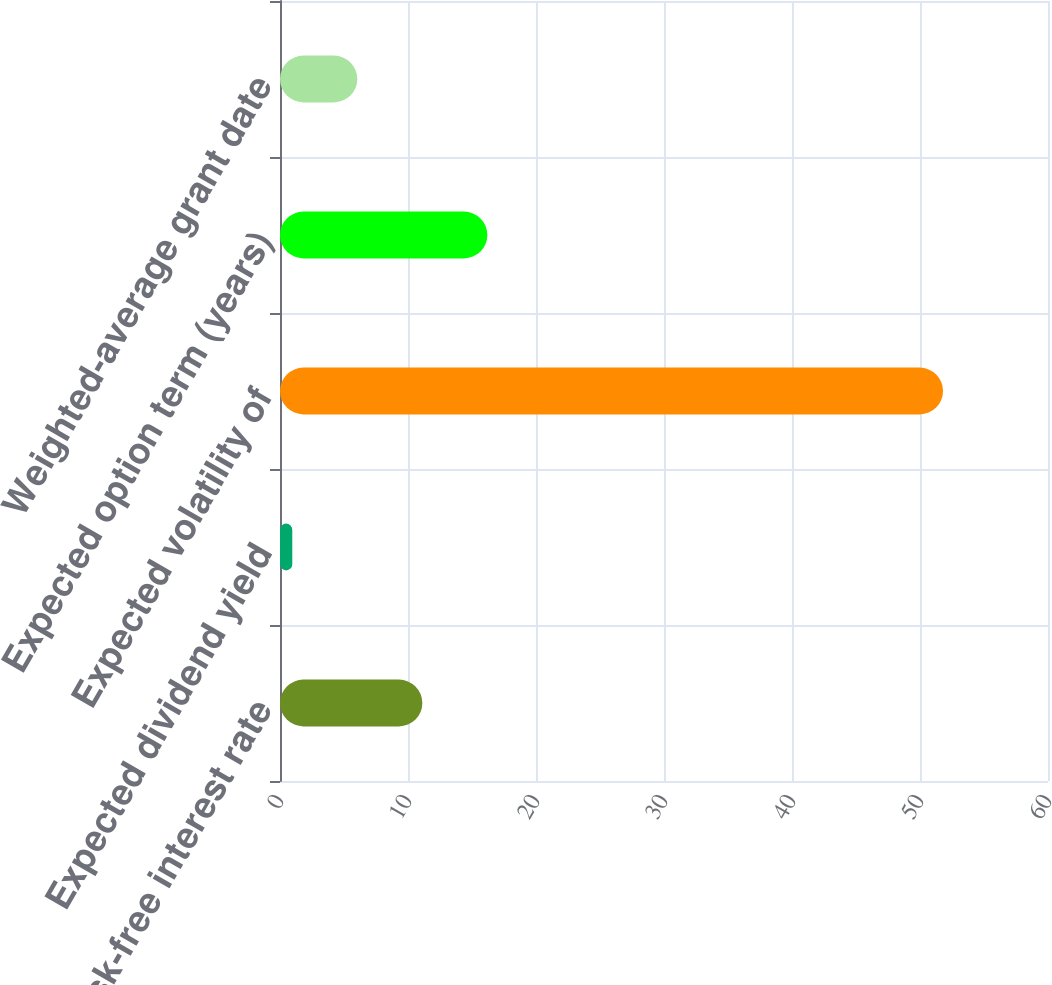Convert chart. <chart><loc_0><loc_0><loc_500><loc_500><bar_chart><fcel>Risk-free interest rate<fcel>Expected dividend yield<fcel>Expected volatility of<fcel>Expected option term (years)<fcel>Weighted-average grant date<nl><fcel>11.12<fcel>0.96<fcel>51.8<fcel>16.2<fcel>6.04<nl></chart> 